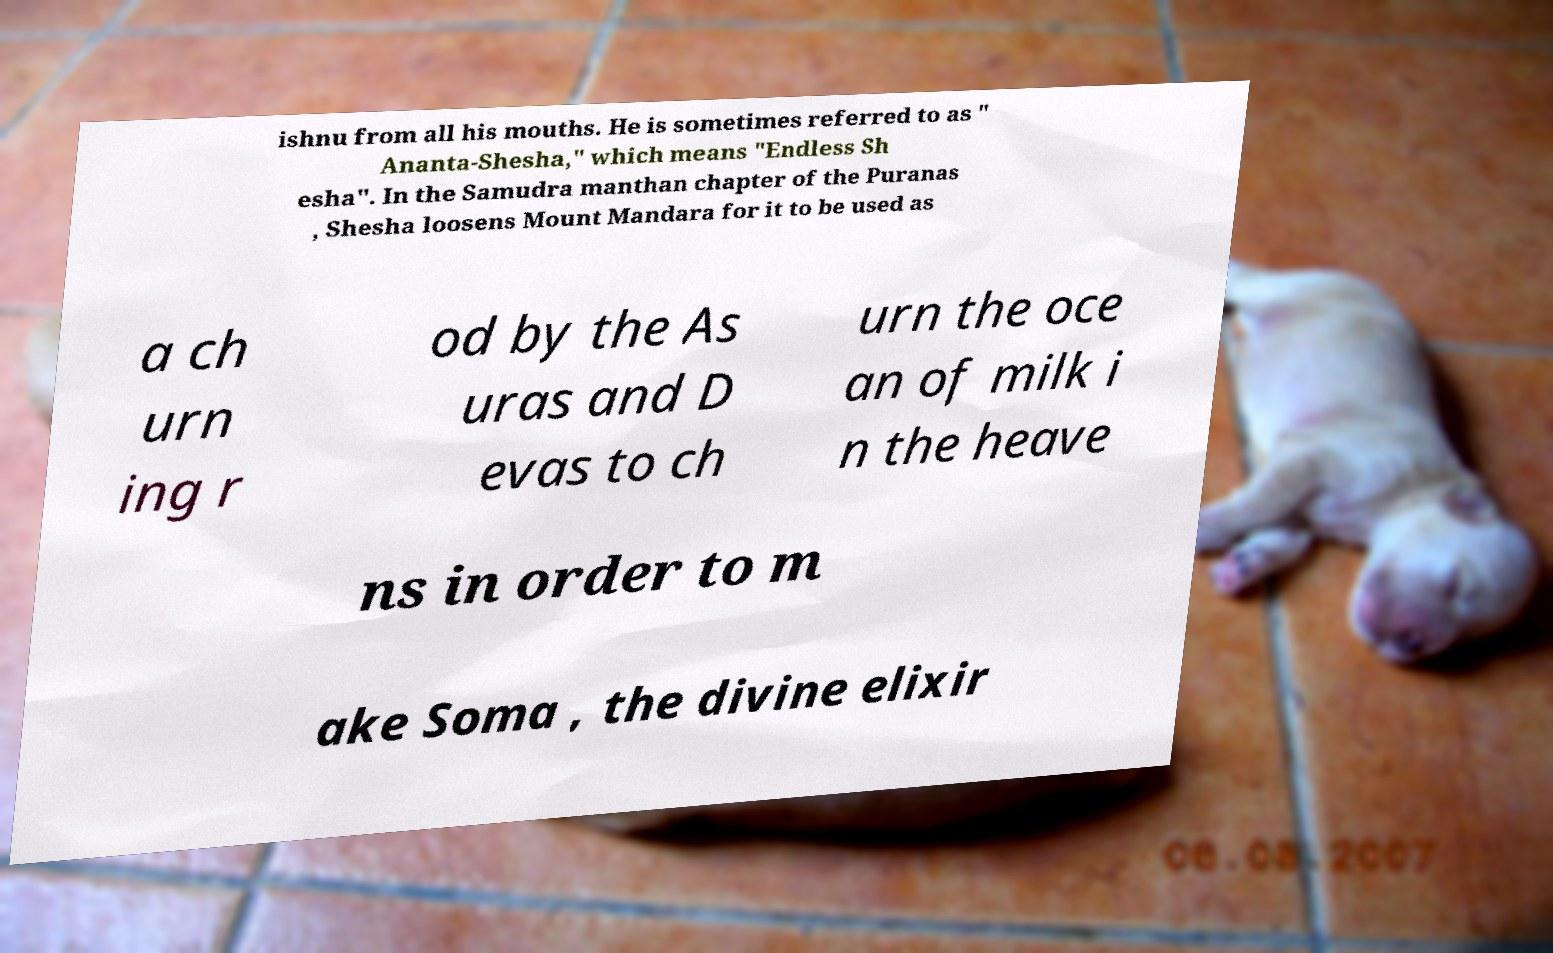There's text embedded in this image that I need extracted. Can you transcribe it verbatim? ishnu from all his mouths. He is sometimes referred to as " Ananta-Shesha," which means "Endless Sh esha". In the Samudra manthan chapter of the Puranas , Shesha loosens Mount Mandara for it to be used as a ch urn ing r od by the As uras and D evas to ch urn the oce an of milk i n the heave ns in order to m ake Soma , the divine elixir 